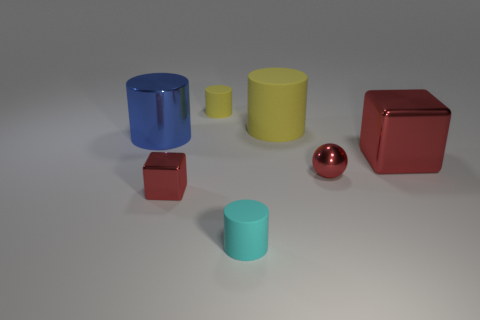Is the ball the same size as the cyan matte thing?
Provide a short and direct response. Yes. There is a red shiny thing that is left of the tiny matte cylinder on the left side of the small cyan object; what is its size?
Offer a very short reply. Small. There is a tiny shiny thing that is the same color as the metal ball; what shape is it?
Your answer should be compact. Cube. How many cylinders are either big green objects or tiny rubber objects?
Your response must be concise. 2. There is a sphere; is it the same size as the red cube that is to the right of the ball?
Keep it short and to the point. No. Are there more tiny red blocks left of the big yellow matte object than large purple rubber blocks?
Your answer should be very brief. Yes. The ball that is made of the same material as the large blue cylinder is what size?
Make the answer very short. Small. Is there a sphere of the same color as the small cube?
Ensure brevity in your answer.  Yes. How many objects are either big blue metallic objects or things that are behind the cyan object?
Offer a terse response. 6. Is the number of cylinders greater than the number of tiny purple cylinders?
Ensure brevity in your answer.  Yes. 